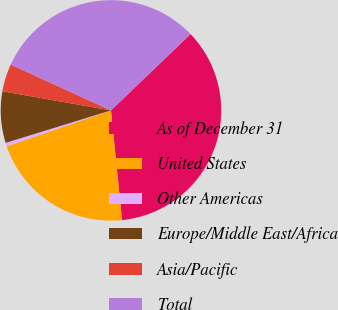<chart> <loc_0><loc_0><loc_500><loc_500><pie_chart><fcel>As of December 31<fcel>United States<fcel>Other Americas<fcel>Europe/Middle East/Africa<fcel>Asia/Pacific<fcel>Total<nl><fcel>35.57%<fcel>21.31%<fcel>0.53%<fcel>7.54%<fcel>4.04%<fcel>31.01%<nl></chart> 